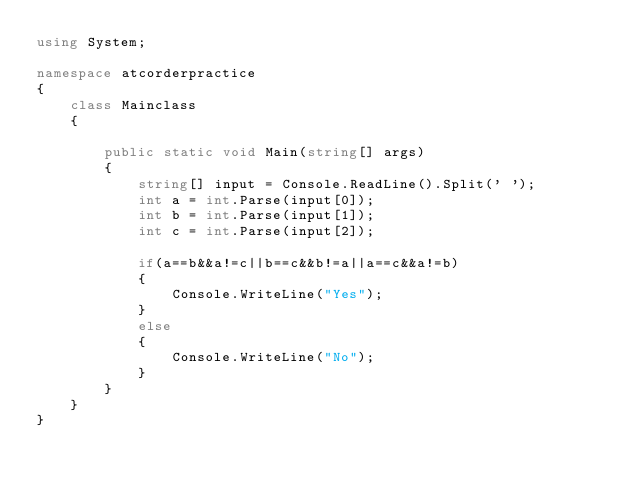Convert code to text. <code><loc_0><loc_0><loc_500><loc_500><_C#_>using System;

namespace atcorderpractice
{
    class Mainclass
    {

        public static void Main(string[] args)
        {
            string[] input = Console.ReadLine().Split(' ');
            int a = int.Parse(input[0]);
            int b = int.Parse(input[1]);
            int c = int.Parse(input[2]);

            if(a==b&&a!=c||b==c&&b!=a||a==c&&a!=b)
            {
                Console.WriteLine("Yes");
            }
            else
            {
                Console.WriteLine("No");
            }
        }
    }
}</code> 